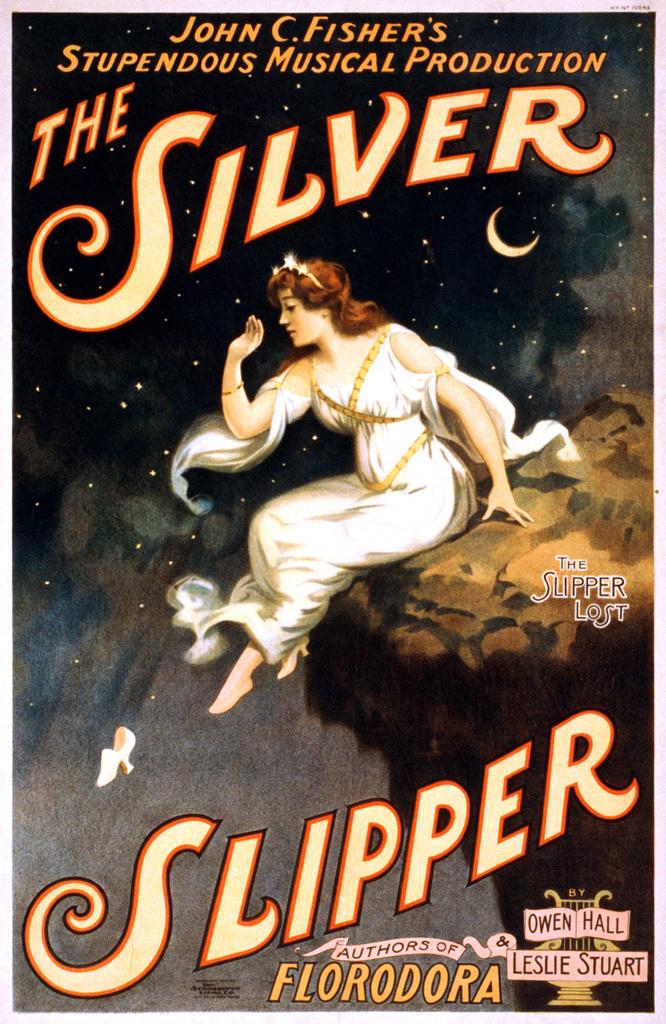Provide a one-sentence caption for the provided image. Cover for The Silver Slipper showing a woman sitting on a cliff. 